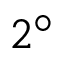Convert formula to latex. <formula><loc_0><loc_0><loc_500><loc_500>2 ^ { \circ }</formula> 